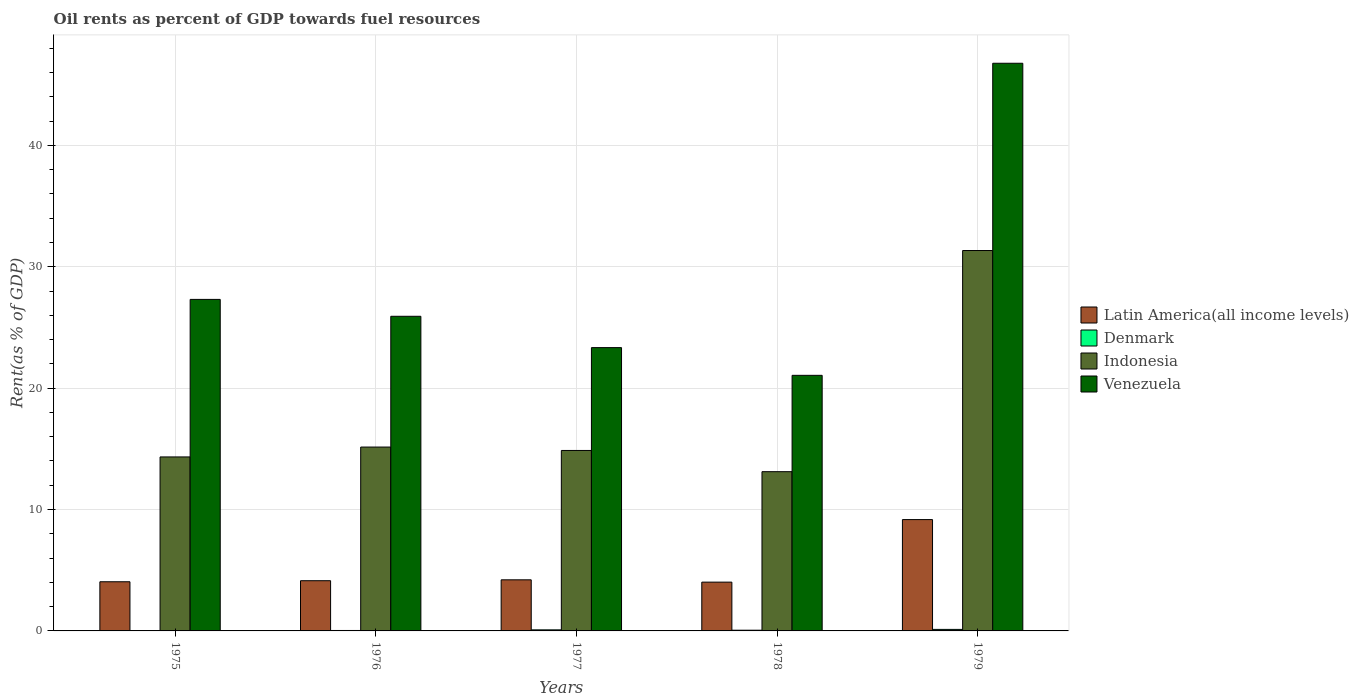How many different coloured bars are there?
Make the answer very short. 4. How many groups of bars are there?
Your answer should be compact. 5. Are the number of bars per tick equal to the number of legend labels?
Provide a short and direct response. Yes. Are the number of bars on each tick of the X-axis equal?
Your response must be concise. Yes. How many bars are there on the 4th tick from the left?
Ensure brevity in your answer.  4. What is the label of the 4th group of bars from the left?
Your response must be concise. 1978. In how many cases, is the number of bars for a given year not equal to the number of legend labels?
Offer a terse response. 0. What is the oil rent in Denmark in 1976?
Offer a very short reply. 0.04. Across all years, what is the maximum oil rent in Indonesia?
Your answer should be very brief. 31.34. Across all years, what is the minimum oil rent in Denmark?
Keep it short and to the point. 0.03. In which year was the oil rent in Indonesia maximum?
Keep it short and to the point. 1979. In which year was the oil rent in Denmark minimum?
Give a very brief answer. 1975. What is the total oil rent in Indonesia in the graph?
Your answer should be very brief. 88.81. What is the difference between the oil rent in Venezuela in 1977 and that in 1978?
Provide a short and direct response. 2.28. What is the difference between the oil rent in Denmark in 1977 and the oil rent in Indonesia in 1976?
Give a very brief answer. -15.06. What is the average oil rent in Denmark per year?
Make the answer very short. 0.07. In the year 1976, what is the difference between the oil rent in Indonesia and oil rent in Denmark?
Your answer should be compact. 15.11. What is the ratio of the oil rent in Denmark in 1975 to that in 1977?
Offer a terse response. 0.31. Is the difference between the oil rent in Indonesia in 1975 and 1978 greater than the difference between the oil rent in Denmark in 1975 and 1978?
Your answer should be very brief. Yes. What is the difference between the highest and the second highest oil rent in Latin America(all income levels)?
Give a very brief answer. 4.96. What is the difference between the highest and the lowest oil rent in Latin America(all income levels)?
Your response must be concise. 5.15. In how many years, is the oil rent in Indonesia greater than the average oil rent in Indonesia taken over all years?
Your response must be concise. 1. What does the 3rd bar from the left in 1976 represents?
Your answer should be very brief. Indonesia. What does the 3rd bar from the right in 1975 represents?
Your answer should be compact. Denmark. Is it the case that in every year, the sum of the oil rent in Denmark and oil rent in Latin America(all income levels) is greater than the oil rent in Venezuela?
Provide a short and direct response. No. How many bars are there?
Keep it short and to the point. 20. How many years are there in the graph?
Your answer should be compact. 5. What is the difference between two consecutive major ticks on the Y-axis?
Your response must be concise. 10. Are the values on the major ticks of Y-axis written in scientific E-notation?
Provide a succinct answer. No. Does the graph contain grids?
Your response must be concise. Yes. How many legend labels are there?
Ensure brevity in your answer.  4. How are the legend labels stacked?
Your answer should be compact. Vertical. What is the title of the graph?
Ensure brevity in your answer.  Oil rents as percent of GDP towards fuel resources. Does "Barbados" appear as one of the legend labels in the graph?
Offer a very short reply. No. What is the label or title of the X-axis?
Your answer should be compact. Years. What is the label or title of the Y-axis?
Give a very brief answer. Rent(as % of GDP). What is the Rent(as % of GDP) in Latin America(all income levels) in 1975?
Provide a succinct answer. 4.05. What is the Rent(as % of GDP) of Denmark in 1975?
Your answer should be very brief. 0.03. What is the Rent(as % of GDP) in Indonesia in 1975?
Your answer should be compact. 14.34. What is the Rent(as % of GDP) of Venezuela in 1975?
Provide a succinct answer. 27.31. What is the Rent(as % of GDP) of Latin America(all income levels) in 1976?
Offer a very short reply. 4.14. What is the Rent(as % of GDP) of Denmark in 1976?
Your response must be concise. 0.04. What is the Rent(as % of GDP) in Indonesia in 1976?
Offer a very short reply. 15.15. What is the Rent(as % of GDP) in Venezuela in 1976?
Provide a succinct answer. 25.92. What is the Rent(as % of GDP) of Latin America(all income levels) in 1977?
Ensure brevity in your answer.  4.21. What is the Rent(as % of GDP) of Denmark in 1977?
Your answer should be compact. 0.09. What is the Rent(as % of GDP) in Indonesia in 1977?
Your answer should be compact. 14.87. What is the Rent(as % of GDP) of Venezuela in 1977?
Give a very brief answer. 23.34. What is the Rent(as % of GDP) of Latin America(all income levels) in 1978?
Offer a very short reply. 4.02. What is the Rent(as % of GDP) of Denmark in 1978?
Give a very brief answer. 0.06. What is the Rent(as % of GDP) of Indonesia in 1978?
Offer a terse response. 13.12. What is the Rent(as % of GDP) of Venezuela in 1978?
Provide a succinct answer. 21.06. What is the Rent(as % of GDP) of Latin America(all income levels) in 1979?
Ensure brevity in your answer.  9.17. What is the Rent(as % of GDP) of Denmark in 1979?
Your answer should be compact. 0.12. What is the Rent(as % of GDP) in Indonesia in 1979?
Your response must be concise. 31.34. What is the Rent(as % of GDP) in Venezuela in 1979?
Offer a very short reply. 46.77. Across all years, what is the maximum Rent(as % of GDP) of Latin America(all income levels)?
Offer a terse response. 9.17. Across all years, what is the maximum Rent(as % of GDP) of Denmark?
Offer a terse response. 0.12. Across all years, what is the maximum Rent(as % of GDP) in Indonesia?
Your answer should be compact. 31.34. Across all years, what is the maximum Rent(as % of GDP) in Venezuela?
Your answer should be very brief. 46.77. Across all years, what is the minimum Rent(as % of GDP) of Latin America(all income levels)?
Your answer should be compact. 4.02. Across all years, what is the minimum Rent(as % of GDP) of Denmark?
Keep it short and to the point. 0.03. Across all years, what is the minimum Rent(as % of GDP) in Indonesia?
Provide a short and direct response. 13.12. Across all years, what is the minimum Rent(as % of GDP) of Venezuela?
Give a very brief answer. 21.06. What is the total Rent(as % of GDP) of Latin America(all income levels) in the graph?
Give a very brief answer. 25.59. What is the total Rent(as % of GDP) in Denmark in the graph?
Ensure brevity in your answer.  0.33. What is the total Rent(as % of GDP) of Indonesia in the graph?
Give a very brief answer. 88.81. What is the total Rent(as % of GDP) of Venezuela in the graph?
Ensure brevity in your answer.  144.41. What is the difference between the Rent(as % of GDP) of Latin America(all income levels) in 1975 and that in 1976?
Provide a succinct answer. -0.09. What is the difference between the Rent(as % of GDP) in Denmark in 1975 and that in 1976?
Keep it short and to the point. -0.01. What is the difference between the Rent(as % of GDP) in Indonesia in 1975 and that in 1976?
Provide a succinct answer. -0.81. What is the difference between the Rent(as % of GDP) in Venezuela in 1975 and that in 1976?
Ensure brevity in your answer.  1.39. What is the difference between the Rent(as % of GDP) in Latin America(all income levels) in 1975 and that in 1977?
Make the answer very short. -0.16. What is the difference between the Rent(as % of GDP) in Denmark in 1975 and that in 1977?
Your answer should be very brief. -0.06. What is the difference between the Rent(as % of GDP) of Indonesia in 1975 and that in 1977?
Give a very brief answer. -0.53. What is the difference between the Rent(as % of GDP) of Venezuela in 1975 and that in 1977?
Keep it short and to the point. 3.97. What is the difference between the Rent(as % of GDP) in Latin America(all income levels) in 1975 and that in 1978?
Your answer should be very brief. 0.03. What is the difference between the Rent(as % of GDP) of Denmark in 1975 and that in 1978?
Offer a very short reply. -0.03. What is the difference between the Rent(as % of GDP) in Indonesia in 1975 and that in 1978?
Ensure brevity in your answer.  1.22. What is the difference between the Rent(as % of GDP) in Venezuela in 1975 and that in 1978?
Provide a succinct answer. 6.26. What is the difference between the Rent(as % of GDP) of Latin America(all income levels) in 1975 and that in 1979?
Provide a succinct answer. -5.12. What is the difference between the Rent(as % of GDP) of Denmark in 1975 and that in 1979?
Provide a succinct answer. -0.1. What is the difference between the Rent(as % of GDP) in Indonesia in 1975 and that in 1979?
Your answer should be very brief. -17.01. What is the difference between the Rent(as % of GDP) in Venezuela in 1975 and that in 1979?
Offer a very short reply. -19.46. What is the difference between the Rent(as % of GDP) in Latin America(all income levels) in 1976 and that in 1977?
Your answer should be very brief. -0.07. What is the difference between the Rent(as % of GDP) of Denmark in 1976 and that in 1977?
Provide a succinct answer. -0.05. What is the difference between the Rent(as % of GDP) of Indonesia in 1976 and that in 1977?
Offer a terse response. 0.28. What is the difference between the Rent(as % of GDP) of Venezuela in 1976 and that in 1977?
Make the answer very short. 2.58. What is the difference between the Rent(as % of GDP) in Latin America(all income levels) in 1976 and that in 1978?
Offer a terse response. 0.12. What is the difference between the Rent(as % of GDP) of Denmark in 1976 and that in 1978?
Ensure brevity in your answer.  -0.02. What is the difference between the Rent(as % of GDP) in Indonesia in 1976 and that in 1978?
Offer a terse response. 2.03. What is the difference between the Rent(as % of GDP) of Venezuela in 1976 and that in 1978?
Your answer should be very brief. 4.87. What is the difference between the Rent(as % of GDP) in Latin America(all income levels) in 1976 and that in 1979?
Give a very brief answer. -5.04. What is the difference between the Rent(as % of GDP) of Denmark in 1976 and that in 1979?
Provide a succinct answer. -0.09. What is the difference between the Rent(as % of GDP) of Indonesia in 1976 and that in 1979?
Ensure brevity in your answer.  -16.19. What is the difference between the Rent(as % of GDP) in Venezuela in 1976 and that in 1979?
Make the answer very short. -20.85. What is the difference between the Rent(as % of GDP) of Latin America(all income levels) in 1977 and that in 1978?
Your response must be concise. 0.19. What is the difference between the Rent(as % of GDP) of Denmark in 1977 and that in 1978?
Offer a very short reply. 0.03. What is the difference between the Rent(as % of GDP) of Indonesia in 1977 and that in 1978?
Your response must be concise. 1.75. What is the difference between the Rent(as % of GDP) of Venezuela in 1977 and that in 1978?
Provide a short and direct response. 2.28. What is the difference between the Rent(as % of GDP) in Latin America(all income levels) in 1977 and that in 1979?
Offer a very short reply. -4.96. What is the difference between the Rent(as % of GDP) in Denmark in 1977 and that in 1979?
Offer a very short reply. -0.04. What is the difference between the Rent(as % of GDP) in Indonesia in 1977 and that in 1979?
Provide a succinct answer. -16.47. What is the difference between the Rent(as % of GDP) in Venezuela in 1977 and that in 1979?
Your answer should be compact. -23.43. What is the difference between the Rent(as % of GDP) of Latin America(all income levels) in 1978 and that in 1979?
Keep it short and to the point. -5.15. What is the difference between the Rent(as % of GDP) in Denmark in 1978 and that in 1979?
Your response must be concise. -0.07. What is the difference between the Rent(as % of GDP) in Indonesia in 1978 and that in 1979?
Provide a succinct answer. -18.22. What is the difference between the Rent(as % of GDP) of Venezuela in 1978 and that in 1979?
Give a very brief answer. -25.71. What is the difference between the Rent(as % of GDP) of Latin America(all income levels) in 1975 and the Rent(as % of GDP) of Denmark in 1976?
Give a very brief answer. 4.01. What is the difference between the Rent(as % of GDP) in Latin America(all income levels) in 1975 and the Rent(as % of GDP) in Indonesia in 1976?
Provide a short and direct response. -11.1. What is the difference between the Rent(as % of GDP) in Latin America(all income levels) in 1975 and the Rent(as % of GDP) in Venezuela in 1976?
Your answer should be very brief. -21.87. What is the difference between the Rent(as % of GDP) of Denmark in 1975 and the Rent(as % of GDP) of Indonesia in 1976?
Provide a short and direct response. -15.12. What is the difference between the Rent(as % of GDP) in Denmark in 1975 and the Rent(as % of GDP) in Venezuela in 1976?
Provide a succinct answer. -25.9. What is the difference between the Rent(as % of GDP) of Indonesia in 1975 and the Rent(as % of GDP) of Venezuela in 1976?
Your answer should be compact. -11.59. What is the difference between the Rent(as % of GDP) in Latin America(all income levels) in 1975 and the Rent(as % of GDP) in Denmark in 1977?
Offer a very short reply. 3.96. What is the difference between the Rent(as % of GDP) of Latin America(all income levels) in 1975 and the Rent(as % of GDP) of Indonesia in 1977?
Offer a terse response. -10.82. What is the difference between the Rent(as % of GDP) of Latin America(all income levels) in 1975 and the Rent(as % of GDP) of Venezuela in 1977?
Make the answer very short. -19.29. What is the difference between the Rent(as % of GDP) in Denmark in 1975 and the Rent(as % of GDP) in Indonesia in 1977?
Offer a very short reply. -14.84. What is the difference between the Rent(as % of GDP) in Denmark in 1975 and the Rent(as % of GDP) in Venezuela in 1977?
Ensure brevity in your answer.  -23.32. What is the difference between the Rent(as % of GDP) in Indonesia in 1975 and the Rent(as % of GDP) in Venezuela in 1977?
Give a very brief answer. -9.01. What is the difference between the Rent(as % of GDP) in Latin America(all income levels) in 1975 and the Rent(as % of GDP) in Denmark in 1978?
Offer a very short reply. 3.99. What is the difference between the Rent(as % of GDP) of Latin America(all income levels) in 1975 and the Rent(as % of GDP) of Indonesia in 1978?
Give a very brief answer. -9.07. What is the difference between the Rent(as % of GDP) in Latin America(all income levels) in 1975 and the Rent(as % of GDP) in Venezuela in 1978?
Provide a short and direct response. -17.01. What is the difference between the Rent(as % of GDP) of Denmark in 1975 and the Rent(as % of GDP) of Indonesia in 1978?
Provide a succinct answer. -13.09. What is the difference between the Rent(as % of GDP) of Denmark in 1975 and the Rent(as % of GDP) of Venezuela in 1978?
Offer a terse response. -21.03. What is the difference between the Rent(as % of GDP) of Indonesia in 1975 and the Rent(as % of GDP) of Venezuela in 1978?
Your answer should be compact. -6.72. What is the difference between the Rent(as % of GDP) of Latin America(all income levels) in 1975 and the Rent(as % of GDP) of Denmark in 1979?
Provide a short and direct response. 3.93. What is the difference between the Rent(as % of GDP) of Latin America(all income levels) in 1975 and the Rent(as % of GDP) of Indonesia in 1979?
Provide a short and direct response. -27.29. What is the difference between the Rent(as % of GDP) in Latin America(all income levels) in 1975 and the Rent(as % of GDP) in Venezuela in 1979?
Make the answer very short. -42.72. What is the difference between the Rent(as % of GDP) of Denmark in 1975 and the Rent(as % of GDP) of Indonesia in 1979?
Give a very brief answer. -31.32. What is the difference between the Rent(as % of GDP) of Denmark in 1975 and the Rent(as % of GDP) of Venezuela in 1979?
Your answer should be compact. -46.74. What is the difference between the Rent(as % of GDP) of Indonesia in 1975 and the Rent(as % of GDP) of Venezuela in 1979?
Offer a terse response. -32.43. What is the difference between the Rent(as % of GDP) in Latin America(all income levels) in 1976 and the Rent(as % of GDP) in Denmark in 1977?
Your answer should be compact. 4.05. What is the difference between the Rent(as % of GDP) of Latin America(all income levels) in 1976 and the Rent(as % of GDP) of Indonesia in 1977?
Make the answer very short. -10.73. What is the difference between the Rent(as % of GDP) in Latin America(all income levels) in 1976 and the Rent(as % of GDP) in Venezuela in 1977?
Your response must be concise. -19.2. What is the difference between the Rent(as % of GDP) in Denmark in 1976 and the Rent(as % of GDP) in Indonesia in 1977?
Offer a very short reply. -14.83. What is the difference between the Rent(as % of GDP) in Denmark in 1976 and the Rent(as % of GDP) in Venezuela in 1977?
Provide a short and direct response. -23.31. What is the difference between the Rent(as % of GDP) of Indonesia in 1976 and the Rent(as % of GDP) of Venezuela in 1977?
Your answer should be very brief. -8.19. What is the difference between the Rent(as % of GDP) in Latin America(all income levels) in 1976 and the Rent(as % of GDP) in Denmark in 1978?
Offer a terse response. 4.08. What is the difference between the Rent(as % of GDP) of Latin America(all income levels) in 1976 and the Rent(as % of GDP) of Indonesia in 1978?
Your answer should be very brief. -8.98. What is the difference between the Rent(as % of GDP) of Latin America(all income levels) in 1976 and the Rent(as % of GDP) of Venezuela in 1978?
Provide a succinct answer. -16.92. What is the difference between the Rent(as % of GDP) of Denmark in 1976 and the Rent(as % of GDP) of Indonesia in 1978?
Offer a very short reply. -13.08. What is the difference between the Rent(as % of GDP) in Denmark in 1976 and the Rent(as % of GDP) in Venezuela in 1978?
Provide a short and direct response. -21.02. What is the difference between the Rent(as % of GDP) of Indonesia in 1976 and the Rent(as % of GDP) of Venezuela in 1978?
Your response must be concise. -5.91. What is the difference between the Rent(as % of GDP) in Latin America(all income levels) in 1976 and the Rent(as % of GDP) in Denmark in 1979?
Your answer should be very brief. 4.01. What is the difference between the Rent(as % of GDP) of Latin America(all income levels) in 1976 and the Rent(as % of GDP) of Indonesia in 1979?
Provide a short and direct response. -27.2. What is the difference between the Rent(as % of GDP) in Latin America(all income levels) in 1976 and the Rent(as % of GDP) in Venezuela in 1979?
Offer a very short reply. -42.63. What is the difference between the Rent(as % of GDP) in Denmark in 1976 and the Rent(as % of GDP) in Indonesia in 1979?
Keep it short and to the point. -31.31. What is the difference between the Rent(as % of GDP) of Denmark in 1976 and the Rent(as % of GDP) of Venezuela in 1979?
Keep it short and to the point. -46.73. What is the difference between the Rent(as % of GDP) in Indonesia in 1976 and the Rent(as % of GDP) in Venezuela in 1979?
Ensure brevity in your answer.  -31.62. What is the difference between the Rent(as % of GDP) of Latin America(all income levels) in 1977 and the Rent(as % of GDP) of Denmark in 1978?
Your response must be concise. 4.15. What is the difference between the Rent(as % of GDP) in Latin America(all income levels) in 1977 and the Rent(as % of GDP) in Indonesia in 1978?
Your response must be concise. -8.91. What is the difference between the Rent(as % of GDP) in Latin America(all income levels) in 1977 and the Rent(as % of GDP) in Venezuela in 1978?
Provide a short and direct response. -16.85. What is the difference between the Rent(as % of GDP) in Denmark in 1977 and the Rent(as % of GDP) in Indonesia in 1978?
Provide a succinct answer. -13.03. What is the difference between the Rent(as % of GDP) in Denmark in 1977 and the Rent(as % of GDP) in Venezuela in 1978?
Your answer should be compact. -20.97. What is the difference between the Rent(as % of GDP) of Indonesia in 1977 and the Rent(as % of GDP) of Venezuela in 1978?
Provide a succinct answer. -6.19. What is the difference between the Rent(as % of GDP) in Latin America(all income levels) in 1977 and the Rent(as % of GDP) in Denmark in 1979?
Provide a succinct answer. 4.09. What is the difference between the Rent(as % of GDP) in Latin America(all income levels) in 1977 and the Rent(as % of GDP) in Indonesia in 1979?
Give a very brief answer. -27.13. What is the difference between the Rent(as % of GDP) in Latin America(all income levels) in 1977 and the Rent(as % of GDP) in Venezuela in 1979?
Your answer should be very brief. -42.56. What is the difference between the Rent(as % of GDP) of Denmark in 1977 and the Rent(as % of GDP) of Indonesia in 1979?
Give a very brief answer. -31.25. What is the difference between the Rent(as % of GDP) in Denmark in 1977 and the Rent(as % of GDP) in Venezuela in 1979?
Your answer should be very brief. -46.68. What is the difference between the Rent(as % of GDP) of Indonesia in 1977 and the Rent(as % of GDP) of Venezuela in 1979?
Offer a very short reply. -31.9. What is the difference between the Rent(as % of GDP) of Latin America(all income levels) in 1978 and the Rent(as % of GDP) of Denmark in 1979?
Provide a succinct answer. 3.89. What is the difference between the Rent(as % of GDP) of Latin America(all income levels) in 1978 and the Rent(as % of GDP) of Indonesia in 1979?
Keep it short and to the point. -27.32. What is the difference between the Rent(as % of GDP) in Latin America(all income levels) in 1978 and the Rent(as % of GDP) in Venezuela in 1979?
Provide a short and direct response. -42.75. What is the difference between the Rent(as % of GDP) of Denmark in 1978 and the Rent(as % of GDP) of Indonesia in 1979?
Offer a terse response. -31.28. What is the difference between the Rent(as % of GDP) of Denmark in 1978 and the Rent(as % of GDP) of Venezuela in 1979?
Provide a succinct answer. -46.71. What is the difference between the Rent(as % of GDP) of Indonesia in 1978 and the Rent(as % of GDP) of Venezuela in 1979?
Offer a terse response. -33.65. What is the average Rent(as % of GDP) in Latin America(all income levels) per year?
Your response must be concise. 5.12. What is the average Rent(as % of GDP) of Denmark per year?
Give a very brief answer. 0.07. What is the average Rent(as % of GDP) of Indonesia per year?
Your response must be concise. 17.76. What is the average Rent(as % of GDP) of Venezuela per year?
Give a very brief answer. 28.88. In the year 1975, what is the difference between the Rent(as % of GDP) in Latin America(all income levels) and Rent(as % of GDP) in Denmark?
Offer a very short reply. 4.02. In the year 1975, what is the difference between the Rent(as % of GDP) of Latin America(all income levels) and Rent(as % of GDP) of Indonesia?
Make the answer very short. -10.29. In the year 1975, what is the difference between the Rent(as % of GDP) of Latin America(all income levels) and Rent(as % of GDP) of Venezuela?
Offer a very short reply. -23.26. In the year 1975, what is the difference between the Rent(as % of GDP) of Denmark and Rent(as % of GDP) of Indonesia?
Give a very brief answer. -14.31. In the year 1975, what is the difference between the Rent(as % of GDP) in Denmark and Rent(as % of GDP) in Venezuela?
Your answer should be very brief. -27.29. In the year 1975, what is the difference between the Rent(as % of GDP) of Indonesia and Rent(as % of GDP) of Venezuela?
Give a very brief answer. -12.98. In the year 1976, what is the difference between the Rent(as % of GDP) of Latin America(all income levels) and Rent(as % of GDP) of Denmark?
Your answer should be compact. 4.1. In the year 1976, what is the difference between the Rent(as % of GDP) of Latin America(all income levels) and Rent(as % of GDP) of Indonesia?
Offer a very short reply. -11.01. In the year 1976, what is the difference between the Rent(as % of GDP) in Latin America(all income levels) and Rent(as % of GDP) in Venezuela?
Provide a short and direct response. -21.79. In the year 1976, what is the difference between the Rent(as % of GDP) of Denmark and Rent(as % of GDP) of Indonesia?
Your answer should be very brief. -15.11. In the year 1976, what is the difference between the Rent(as % of GDP) of Denmark and Rent(as % of GDP) of Venezuela?
Keep it short and to the point. -25.89. In the year 1976, what is the difference between the Rent(as % of GDP) in Indonesia and Rent(as % of GDP) in Venezuela?
Your answer should be very brief. -10.77. In the year 1977, what is the difference between the Rent(as % of GDP) in Latin America(all income levels) and Rent(as % of GDP) in Denmark?
Make the answer very short. 4.12. In the year 1977, what is the difference between the Rent(as % of GDP) in Latin America(all income levels) and Rent(as % of GDP) in Indonesia?
Keep it short and to the point. -10.66. In the year 1977, what is the difference between the Rent(as % of GDP) of Latin America(all income levels) and Rent(as % of GDP) of Venezuela?
Provide a succinct answer. -19.13. In the year 1977, what is the difference between the Rent(as % of GDP) of Denmark and Rent(as % of GDP) of Indonesia?
Your answer should be compact. -14.78. In the year 1977, what is the difference between the Rent(as % of GDP) of Denmark and Rent(as % of GDP) of Venezuela?
Keep it short and to the point. -23.25. In the year 1977, what is the difference between the Rent(as % of GDP) in Indonesia and Rent(as % of GDP) in Venezuela?
Offer a terse response. -8.47. In the year 1978, what is the difference between the Rent(as % of GDP) in Latin America(all income levels) and Rent(as % of GDP) in Denmark?
Your response must be concise. 3.96. In the year 1978, what is the difference between the Rent(as % of GDP) in Latin America(all income levels) and Rent(as % of GDP) in Indonesia?
Provide a short and direct response. -9.1. In the year 1978, what is the difference between the Rent(as % of GDP) of Latin America(all income levels) and Rent(as % of GDP) of Venezuela?
Keep it short and to the point. -17.04. In the year 1978, what is the difference between the Rent(as % of GDP) in Denmark and Rent(as % of GDP) in Indonesia?
Keep it short and to the point. -13.06. In the year 1978, what is the difference between the Rent(as % of GDP) of Denmark and Rent(as % of GDP) of Venezuela?
Your response must be concise. -21. In the year 1978, what is the difference between the Rent(as % of GDP) in Indonesia and Rent(as % of GDP) in Venezuela?
Give a very brief answer. -7.94. In the year 1979, what is the difference between the Rent(as % of GDP) in Latin America(all income levels) and Rent(as % of GDP) in Denmark?
Your response must be concise. 9.05. In the year 1979, what is the difference between the Rent(as % of GDP) in Latin America(all income levels) and Rent(as % of GDP) in Indonesia?
Provide a short and direct response. -22.17. In the year 1979, what is the difference between the Rent(as % of GDP) of Latin America(all income levels) and Rent(as % of GDP) of Venezuela?
Offer a very short reply. -37.6. In the year 1979, what is the difference between the Rent(as % of GDP) in Denmark and Rent(as % of GDP) in Indonesia?
Make the answer very short. -31.22. In the year 1979, what is the difference between the Rent(as % of GDP) in Denmark and Rent(as % of GDP) in Venezuela?
Provide a short and direct response. -46.65. In the year 1979, what is the difference between the Rent(as % of GDP) of Indonesia and Rent(as % of GDP) of Venezuela?
Your answer should be compact. -15.43. What is the ratio of the Rent(as % of GDP) in Latin America(all income levels) in 1975 to that in 1976?
Give a very brief answer. 0.98. What is the ratio of the Rent(as % of GDP) in Denmark in 1975 to that in 1976?
Provide a succinct answer. 0.74. What is the ratio of the Rent(as % of GDP) in Indonesia in 1975 to that in 1976?
Provide a short and direct response. 0.95. What is the ratio of the Rent(as % of GDP) of Venezuela in 1975 to that in 1976?
Provide a short and direct response. 1.05. What is the ratio of the Rent(as % of GDP) in Latin America(all income levels) in 1975 to that in 1977?
Ensure brevity in your answer.  0.96. What is the ratio of the Rent(as % of GDP) in Denmark in 1975 to that in 1977?
Keep it short and to the point. 0.31. What is the ratio of the Rent(as % of GDP) of Indonesia in 1975 to that in 1977?
Your answer should be compact. 0.96. What is the ratio of the Rent(as % of GDP) of Venezuela in 1975 to that in 1977?
Make the answer very short. 1.17. What is the ratio of the Rent(as % of GDP) in Latin America(all income levels) in 1975 to that in 1978?
Make the answer very short. 1.01. What is the ratio of the Rent(as % of GDP) of Denmark in 1975 to that in 1978?
Make the answer very short. 0.45. What is the ratio of the Rent(as % of GDP) in Indonesia in 1975 to that in 1978?
Your answer should be very brief. 1.09. What is the ratio of the Rent(as % of GDP) of Venezuela in 1975 to that in 1978?
Offer a terse response. 1.3. What is the ratio of the Rent(as % of GDP) of Latin America(all income levels) in 1975 to that in 1979?
Give a very brief answer. 0.44. What is the ratio of the Rent(as % of GDP) of Denmark in 1975 to that in 1979?
Your answer should be compact. 0.21. What is the ratio of the Rent(as % of GDP) of Indonesia in 1975 to that in 1979?
Make the answer very short. 0.46. What is the ratio of the Rent(as % of GDP) of Venezuela in 1975 to that in 1979?
Keep it short and to the point. 0.58. What is the ratio of the Rent(as % of GDP) of Latin America(all income levels) in 1976 to that in 1977?
Your answer should be compact. 0.98. What is the ratio of the Rent(as % of GDP) in Denmark in 1976 to that in 1977?
Make the answer very short. 0.42. What is the ratio of the Rent(as % of GDP) in Indonesia in 1976 to that in 1977?
Your answer should be compact. 1.02. What is the ratio of the Rent(as % of GDP) of Venezuela in 1976 to that in 1977?
Your answer should be very brief. 1.11. What is the ratio of the Rent(as % of GDP) in Latin America(all income levels) in 1976 to that in 1978?
Keep it short and to the point. 1.03. What is the ratio of the Rent(as % of GDP) in Denmark in 1976 to that in 1978?
Ensure brevity in your answer.  0.62. What is the ratio of the Rent(as % of GDP) in Indonesia in 1976 to that in 1978?
Offer a very short reply. 1.15. What is the ratio of the Rent(as % of GDP) of Venezuela in 1976 to that in 1978?
Make the answer very short. 1.23. What is the ratio of the Rent(as % of GDP) of Latin America(all income levels) in 1976 to that in 1979?
Your answer should be very brief. 0.45. What is the ratio of the Rent(as % of GDP) in Denmark in 1976 to that in 1979?
Give a very brief answer. 0.29. What is the ratio of the Rent(as % of GDP) of Indonesia in 1976 to that in 1979?
Your answer should be very brief. 0.48. What is the ratio of the Rent(as % of GDP) in Venezuela in 1976 to that in 1979?
Make the answer very short. 0.55. What is the ratio of the Rent(as % of GDP) in Latin America(all income levels) in 1977 to that in 1978?
Make the answer very short. 1.05. What is the ratio of the Rent(as % of GDP) in Denmark in 1977 to that in 1978?
Your answer should be compact. 1.48. What is the ratio of the Rent(as % of GDP) in Indonesia in 1977 to that in 1978?
Offer a terse response. 1.13. What is the ratio of the Rent(as % of GDP) in Venezuela in 1977 to that in 1978?
Ensure brevity in your answer.  1.11. What is the ratio of the Rent(as % of GDP) in Latin America(all income levels) in 1977 to that in 1979?
Your answer should be compact. 0.46. What is the ratio of the Rent(as % of GDP) of Denmark in 1977 to that in 1979?
Offer a very short reply. 0.7. What is the ratio of the Rent(as % of GDP) of Indonesia in 1977 to that in 1979?
Your answer should be compact. 0.47. What is the ratio of the Rent(as % of GDP) in Venezuela in 1977 to that in 1979?
Keep it short and to the point. 0.5. What is the ratio of the Rent(as % of GDP) in Latin America(all income levels) in 1978 to that in 1979?
Make the answer very short. 0.44. What is the ratio of the Rent(as % of GDP) of Denmark in 1978 to that in 1979?
Your answer should be compact. 0.47. What is the ratio of the Rent(as % of GDP) in Indonesia in 1978 to that in 1979?
Offer a terse response. 0.42. What is the ratio of the Rent(as % of GDP) of Venezuela in 1978 to that in 1979?
Provide a succinct answer. 0.45. What is the difference between the highest and the second highest Rent(as % of GDP) in Latin America(all income levels)?
Ensure brevity in your answer.  4.96. What is the difference between the highest and the second highest Rent(as % of GDP) of Denmark?
Your answer should be compact. 0.04. What is the difference between the highest and the second highest Rent(as % of GDP) in Indonesia?
Your answer should be compact. 16.19. What is the difference between the highest and the second highest Rent(as % of GDP) of Venezuela?
Make the answer very short. 19.46. What is the difference between the highest and the lowest Rent(as % of GDP) of Latin America(all income levels)?
Offer a terse response. 5.15. What is the difference between the highest and the lowest Rent(as % of GDP) in Denmark?
Offer a terse response. 0.1. What is the difference between the highest and the lowest Rent(as % of GDP) of Indonesia?
Your response must be concise. 18.22. What is the difference between the highest and the lowest Rent(as % of GDP) in Venezuela?
Keep it short and to the point. 25.71. 